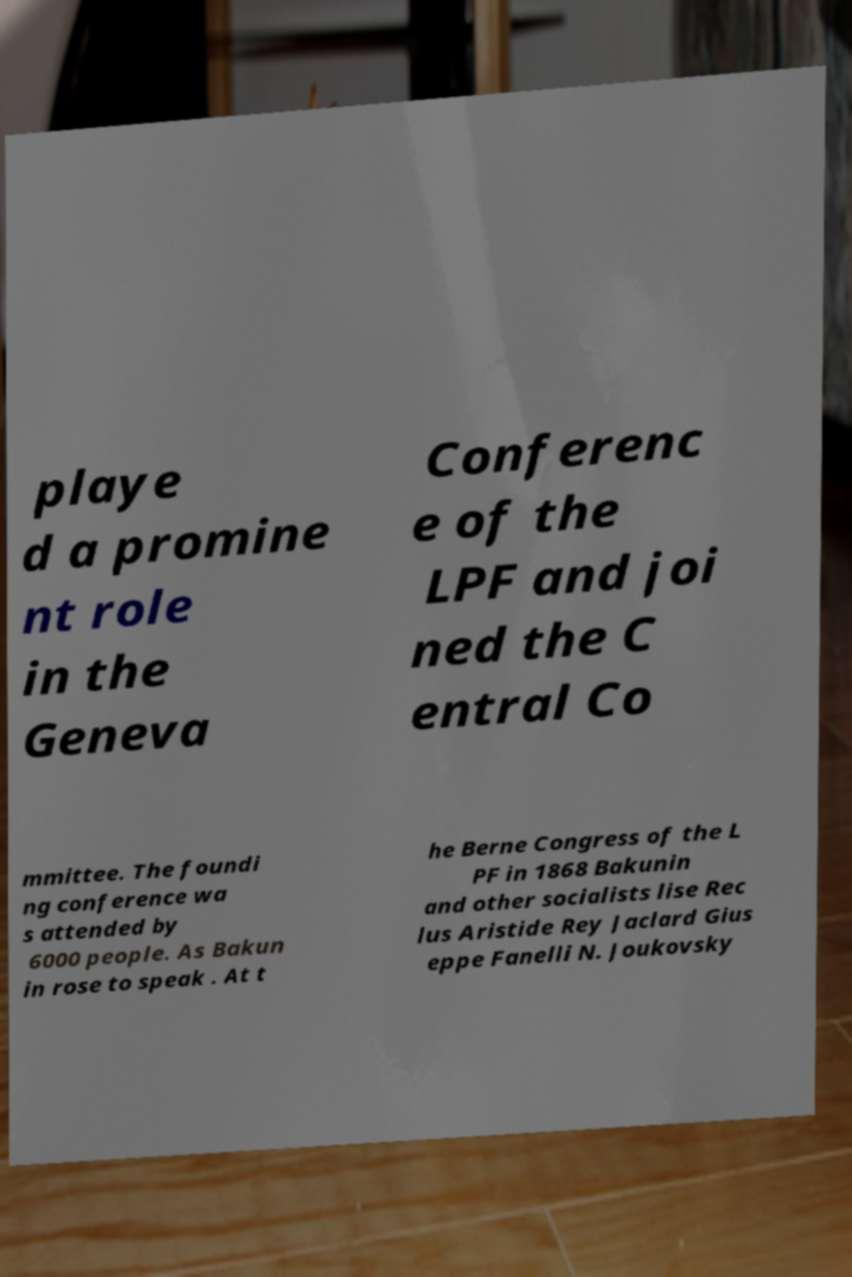Could you extract and type out the text from this image? playe d a promine nt role in the Geneva Conferenc e of the LPF and joi ned the C entral Co mmittee. The foundi ng conference wa s attended by 6000 people. As Bakun in rose to speak . At t he Berne Congress of the L PF in 1868 Bakunin and other socialists lise Rec lus Aristide Rey Jaclard Gius eppe Fanelli N. Joukovsky 